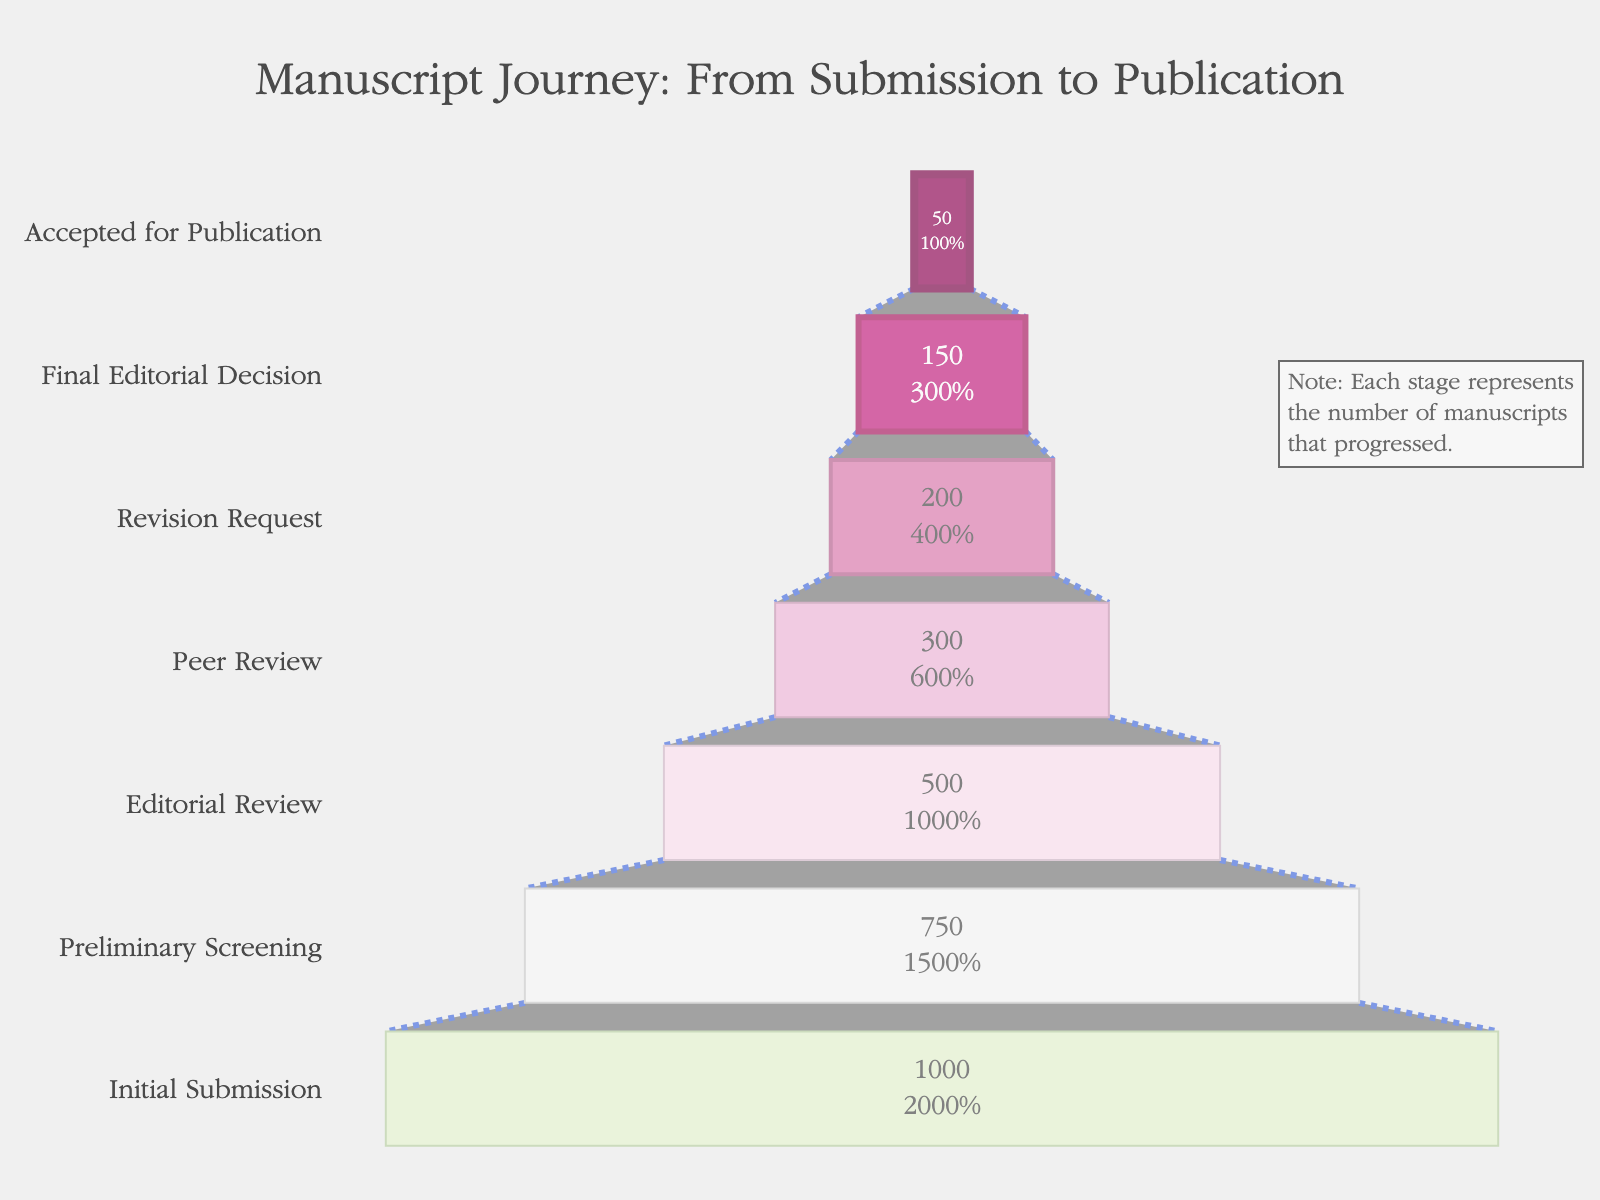What is the title of the chart? The title of the chart is usually located at the top of the figure, and it summarizes the main subject of the data presented. Here, the title reads "Manuscript Journey: From Submission to Publication".
Answer: Manuscript Journey: From Submission to Publication How many manuscripts were initially submitted? The initial count of manuscripts is indicated at the top of the funnel and is labeled "Initial Submission". According to the chart, 1,000 manuscripts were initially submitted.
Answer: 1,000 What percentage of manuscripts pass the editorial review stage? To find the percentage of manuscripts that pass the editorial review stage, locate the number of manuscripts at that stage and then divide it by the initial number of manuscripts (1,000). Multiply by 100 to convert to a percentage. The editorial review stage has 500 manuscripts (500/1,000 * 100 = 50%).
Answer: 50% At which stage do the number of manuscripts drop below half of the initial submission? By examining the chart, we can see that below half of 1,000 (which is 500) is reached at the Peer Review stage, which has 300 manuscripts.
Answer: Peer Review What is the difference in number of manuscripts between the preliminary screening and the revision request stages? Find the number of manuscripts at both stages and subtract the latter from the former. Preliminary Screening has 750 manuscripts, and Revision Request has 200 manuscripts. So, 750 - 200 = 550.
Answer: 550 Which stage has the least number of manuscripts left? Examine the lowest count presented in the chart which can be found at the bottom stage. The "Accepted for Publication" stage has the least number of 50 manuscripts.
Answer: Accepted for Publication What is the percentage of manuscripts that make it from the initial submission to the final editorial decision? To find this percentage, divide the number of manuscripts at the final editorial decision stage by the number initially submitted (150/1,000) and then multiply by 100. This calculation gives 15%.
Answer: 15% How many manuscripts are rejected between the editorial review and peer review stages? Subtract the number of manuscripts in the peer review stage from the number in the editorial review stage (500 - 300), which results in 200 manuscripts being rejected.
Answer: 200 Compare the number of manuscripts in the initial submission to the number that received a revision request. The initial submission has 1,000 manuscripts while the revision request stage has 200. Therefore, the initial submission has 800 more manuscripts compared to the revision request stage (1,000 - 200).
Answer: 800 